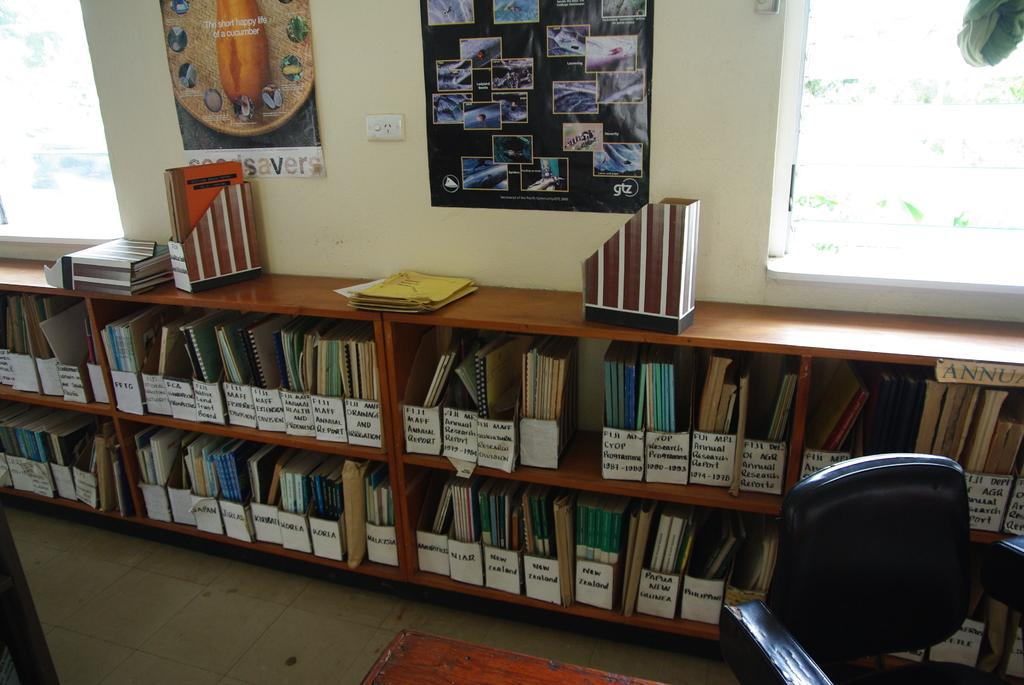<image>
Share a concise interpretation of the image provided. A poster on the wall above bookcases is about the short happy life of a cucumber. 